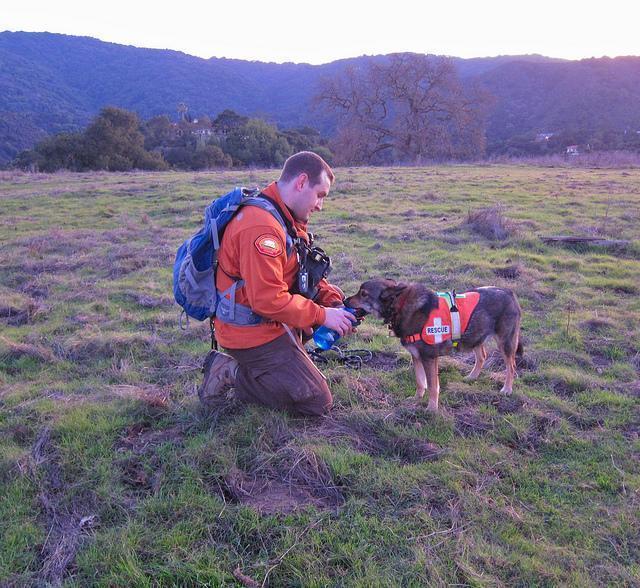How many people are shown?
Give a very brief answer. 1. 